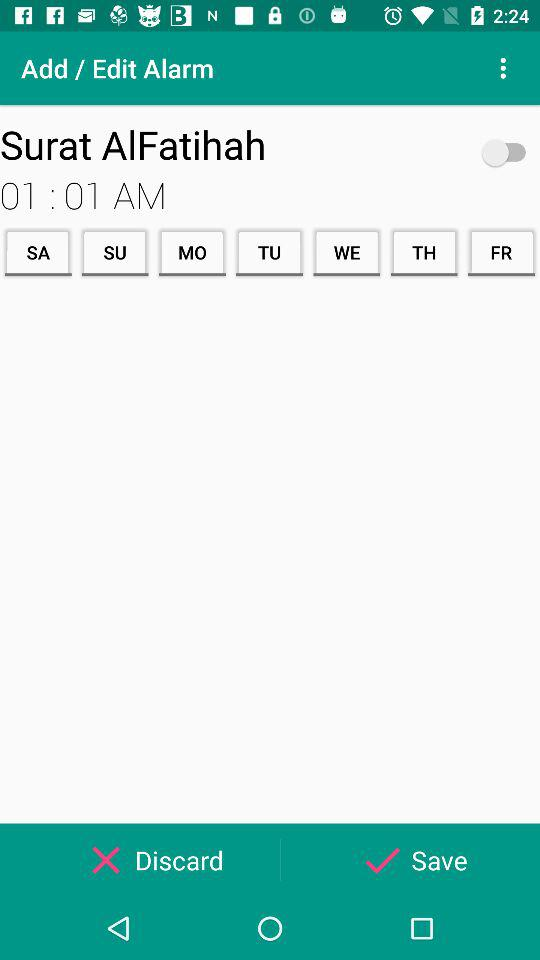What is the label of the alarm? The label of the alarm is "Surat AlFatihah". 